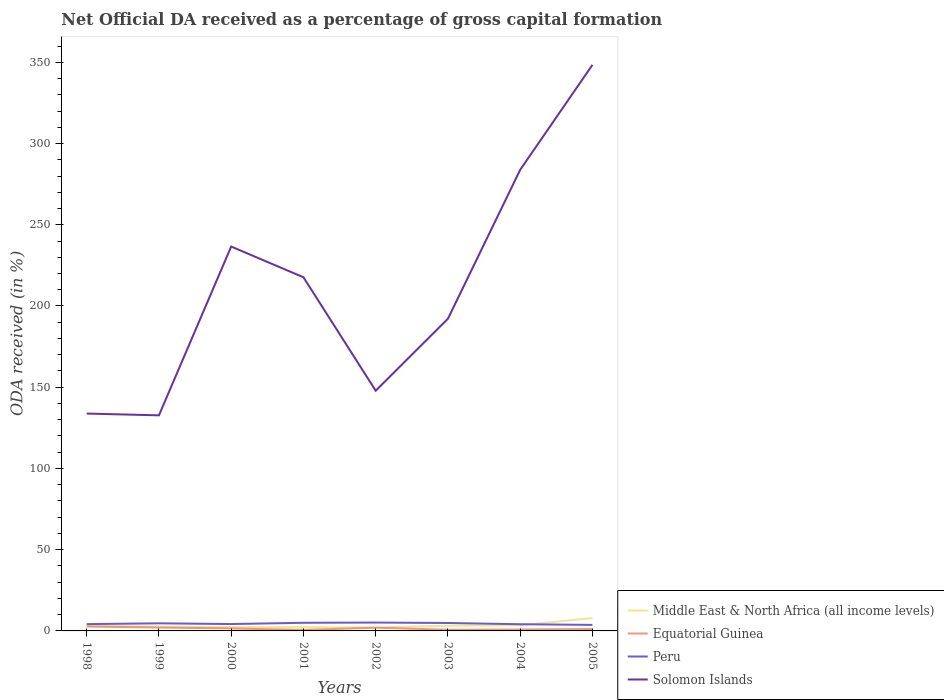How many different coloured lines are there?
Give a very brief answer. 4. Is the number of lines equal to the number of legend labels?
Your answer should be compact. Yes. Across all years, what is the maximum net ODA received in Middle East & North Africa (all income levels)?
Provide a short and direct response. 2.15. In which year was the net ODA received in Solomon Islands maximum?
Give a very brief answer. 1999. What is the total net ODA received in Solomon Islands in the graph?
Your answer should be very brief. -59.48. What is the difference between the highest and the second highest net ODA received in Equatorial Guinea?
Your response must be concise. 2.1. Is the net ODA received in Middle East & North Africa (all income levels) strictly greater than the net ODA received in Solomon Islands over the years?
Your answer should be compact. Yes. How many lines are there?
Your response must be concise. 4. What is the difference between two consecutive major ticks on the Y-axis?
Your answer should be very brief. 50. Are the values on the major ticks of Y-axis written in scientific E-notation?
Your answer should be compact. No. Does the graph contain grids?
Your answer should be compact. No. How are the legend labels stacked?
Provide a short and direct response. Vertical. What is the title of the graph?
Provide a short and direct response. Net Official DA received as a percentage of gross capital formation. What is the label or title of the Y-axis?
Give a very brief answer. ODA received (in %). What is the ODA received (in %) in Middle East & North Africa (all income levels) in 1998?
Your answer should be very brief. 3.15. What is the ODA received (in %) of Equatorial Guinea in 1998?
Offer a very short reply. 2.72. What is the ODA received (in %) in Peru in 1998?
Keep it short and to the point. 4.19. What is the ODA received (in %) in Solomon Islands in 1998?
Provide a short and direct response. 133.79. What is the ODA received (in %) in Middle East & North Africa (all income levels) in 1999?
Give a very brief answer. 2.72. What is the ODA received (in %) in Equatorial Guinea in 1999?
Your response must be concise. 2.1. What is the ODA received (in %) in Peru in 1999?
Provide a short and direct response. 4.68. What is the ODA received (in %) in Solomon Islands in 1999?
Give a very brief answer. 132.69. What is the ODA received (in %) of Middle East & North Africa (all income levels) in 2000?
Make the answer very short. 2.32. What is the ODA received (in %) of Equatorial Guinea in 2000?
Your response must be concise. 1.55. What is the ODA received (in %) of Peru in 2000?
Offer a terse response. 4.23. What is the ODA received (in %) in Solomon Islands in 2000?
Make the answer very short. 236.59. What is the ODA received (in %) of Middle East & North Africa (all income levels) in 2001?
Your answer should be very brief. 2.3. What is the ODA received (in %) in Equatorial Guinea in 2001?
Offer a terse response. 0.61. What is the ODA received (in %) of Peru in 2001?
Give a very brief answer. 5.01. What is the ODA received (in %) in Solomon Islands in 2001?
Your response must be concise. 217.68. What is the ODA received (in %) of Middle East & North Africa (all income levels) in 2002?
Offer a very short reply. 2.15. What is the ODA received (in %) of Equatorial Guinea in 2002?
Make the answer very short. 2. What is the ODA received (in %) of Peru in 2002?
Ensure brevity in your answer.  5.14. What is the ODA received (in %) of Solomon Islands in 2002?
Offer a terse response. 147.85. What is the ODA received (in %) of Middle East & North Africa (all income levels) in 2003?
Offer a very short reply. 3.2. What is the ODA received (in %) in Equatorial Guinea in 2003?
Your response must be concise. 0.72. What is the ODA received (in %) in Peru in 2003?
Your answer should be compact. 4.88. What is the ODA received (in %) in Solomon Islands in 2003?
Your answer should be very brief. 192.17. What is the ODA received (in %) in Middle East & North Africa (all income levels) in 2004?
Your response must be concise. 3.5. What is the ODA received (in %) of Equatorial Guinea in 2004?
Give a very brief answer. 0.86. What is the ODA received (in %) of Peru in 2004?
Your answer should be compact. 4.12. What is the ODA received (in %) in Solomon Islands in 2004?
Offer a very short reply. 283.85. What is the ODA received (in %) of Middle East & North Africa (all income levels) in 2005?
Offer a terse response. 7.89. What is the ODA received (in %) in Equatorial Guinea in 2005?
Provide a succinct answer. 1.18. What is the ODA received (in %) of Peru in 2005?
Provide a succinct answer. 3.71. What is the ODA received (in %) in Solomon Islands in 2005?
Your response must be concise. 348.44. Across all years, what is the maximum ODA received (in %) in Middle East & North Africa (all income levels)?
Make the answer very short. 7.89. Across all years, what is the maximum ODA received (in %) in Equatorial Guinea?
Give a very brief answer. 2.72. Across all years, what is the maximum ODA received (in %) of Peru?
Keep it short and to the point. 5.14. Across all years, what is the maximum ODA received (in %) of Solomon Islands?
Give a very brief answer. 348.44. Across all years, what is the minimum ODA received (in %) of Middle East & North Africa (all income levels)?
Ensure brevity in your answer.  2.15. Across all years, what is the minimum ODA received (in %) of Equatorial Guinea?
Your answer should be very brief. 0.61. Across all years, what is the minimum ODA received (in %) in Peru?
Give a very brief answer. 3.71. Across all years, what is the minimum ODA received (in %) in Solomon Islands?
Offer a terse response. 132.69. What is the total ODA received (in %) in Middle East & North Africa (all income levels) in the graph?
Keep it short and to the point. 27.24. What is the total ODA received (in %) of Equatorial Guinea in the graph?
Give a very brief answer. 11.74. What is the total ODA received (in %) of Peru in the graph?
Offer a very short reply. 35.96. What is the total ODA received (in %) in Solomon Islands in the graph?
Your response must be concise. 1693.06. What is the difference between the ODA received (in %) of Middle East & North Africa (all income levels) in 1998 and that in 1999?
Your response must be concise. 0.42. What is the difference between the ODA received (in %) in Equatorial Guinea in 1998 and that in 1999?
Offer a very short reply. 0.62. What is the difference between the ODA received (in %) in Peru in 1998 and that in 1999?
Make the answer very short. -0.49. What is the difference between the ODA received (in %) of Solomon Islands in 1998 and that in 1999?
Your response must be concise. 1.1. What is the difference between the ODA received (in %) of Middle East & North Africa (all income levels) in 1998 and that in 2000?
Provide a succinct answer. 0.82. What is the difference between the ODA received (in %) of Equatorial Guinea in 1998 and that in 2000?
Provide a short and direct response. 1.17. What is the difference between the ODA received (in %) in Peru in 1998 and that in 2000?
Offer a very short reply. -0.04. What is the difference between the ODA received (in %) of Solomon Islands in 1998 and that in 2000?
Your response must be concise. -102.81. What is the difference between the ODA received (in %) in Middle East & North Africa (all income levels) in 1998 and that in 2001?
Ensure brevity in your answer.  0.84. What is the difference between the ODA received (in %) of Equatorial Guinea in 1998 and that in 2001?
Your answer should be compact. 2.1. What is the difference between the ODA received (in %) of Peru in 1998 and that in 2001?
Offer a very short reply. -0.82. What is the difference between the ODA received (in %) in Solomon Islands in 1998 and that in 2001?
Offer a terse response. -83.89. What is the difference between the ODA received (in %) of Middle East & North Africa (all income levels) in 1998 and that in 2002?
Your answer should be compact. 1. What is the difference between the ODA received (in %) in Equatorial Guinea in 1998 and that in 2002?
Provide a succinct answer. 0.71. What is the difference between the ODA received (in %) in Peru in 1998 and that in 2002?
Offer a very short reply. -0.95. What is the difference between the ODA received (in %) in Solomon Islands in 1998 and that in 2002?
Offer a terse response. -14.06. What is the difference between the ODA received (in %) of Middle East & North Africa (all income levels) in 1998 and that in 2003?
Your answer should be very brief. -0.05. What is the difference between the ODA received (in %) in Equatorial Guinea in 1998 and that in 2003?
Your response must be concise. 1.99. What is the difference between the ODA received (in %) in Peru in 1998 and that in 2003?
Provide a short and direct response. -0.69. What is the difference between the ODA received (in %) of Solomon Islands in 1998 and that in 2003?
Provide a short and direct response. -58.38. What is the difference between the ODA received (in %) of Middle East & North Africa (all income levels) in 1998 and that in 2004?
Ensure brevity in your answer.  -0.36. What is the difference between the ODA received (in %) of Equatorial Guinea in 1998 and that in 2004?
Your answer should be compact. 1.86. What is the difference between the ODA received (in %) in Peru in 1998 and that in 2004?
Make the answer very short. 0.07. What is the difference between the ODA received (in %) in Solomon Islands in 1998 and that in 2004?
Offer a very short reply. -150.07. What is the difference between the ODA received (in %) in Middle East & North Africa (all income levels) in 1998 and that in 2005?
Your response must be concise. -4.75. What is the difference between the ODA received (in %) of Equatorial Guinea in 1998 and that in 2005?
Give a very brief answer. 1.54. What is the difference between the ODA received (in %) in Peru in 1998 and that in 2005?
Give a very brief answer. 0.48. What is the difference between the ODA received (in %) of Solomon Islands in 1998 and that in 2005?
Provide a short and direct response. -214.65. What is the difference between the ODA received (in %) in Middle East & North Africa (all income levels) in 1999 and that in 2000?
Your answer should be compact. 0.4. What is the difference between the ODA received (in %) in Equatorial Guinea in 1999 and that in 2000?
Your answer should be compact. 0.55. What is the difference between the ODA received (in %) in Peru in 1999 and that in 2000?
Make the answer very short. 0.45. What is the difference between the ODA received (in %) in Solomon Islands in 1999 and that in 2000?
Keep it short and to the point. -103.91. What is the difference between the ODA received (in %) in Middle East & North Africa (all income levels) in 1999 and that in 2001?
Your response must be concise. 0.42. What is the difference between the ODA received (in %) of Equatorial Guinea in 1999 and that in 2001?
Your answer should be very brief. 1.49. What is the difference between the ODA received (in %) of Peru in 1999 and that in 2001?
Offer a terse response. -0.33. What is the difference between the ODA received (in %) of Solomon Islands in 1999 and that in 2001?
Offer a terse response. -84.99. What is the difference between the ODA received (in %) in Middle East & North Africa (all income levels) in 1999 and that in 2002?
Give a very brief answer. 0.57. What is the difference between the ODA received (in %) of Equatorial Guinea in 1999 and that in 2002?
Your answer should be compact. 0.1. What is the difference between the ODA received (in %) of Peru in 1999 and that in 2002?
Make the answer very short. -0.46. What is the difference between the ODA received (in %) in Solomon Islands in 1999 and that in 2002?
Keep it short and to the point. -15.16. What is the difference between the ODA received (in %) in Middle East & North Africa (all income levels) in 1999 and that in 2003?
Give a very brief answer. -0.48. What is the difference between the ODA received (in %) in Equatorial Guinea in 1999 and that in 2003?
Your answer should be very brief. 1.37. What is the difference between the ODA received (in %) in Peru in 1999 and that in 2003?
Offer a terse response. -0.2. What is the difference between the ODA received (in %) in Solomon Islands in 1999 and that in 2003?
Ensure brevity in your answer.  -59.48. What is the difference between the ODA received (in %) in Middle East & North Africa (all income levels) in 1999 and that in 2004?
Give a very brief answer. -0.78. What is the difference between the ODA received (in %) of Equatorial Guinea in 1999 and that in 2004?
Provide a short and direct response. 1.24. What is the difference between the ODA received (in %) in Peru in 1999 and that in 2004?
Your answer should be compact. 0.56. What is the difference between the ODA received (in %) of Solomon Islands in 1999 and that in 2004?
Give a very brief answer. -151.17. What is the difference between the ODA received (in %) of Middle East & North Africa (all income levels) in 1999 and that in 2005?
Ensure brevity in your answer.  -5.17. What is the difference between the ODA received (in %) in Equatorial Guinea in 1999 and that in 2005?
Make the answer very short. 0.92. What is the difference between the ODA received (in %) of Peru in 1999 and that in 2005?
Your response must be concise. 0.97. What is the difference between the ODA received (in %) in Solomon Islands in 1999 and that in 2005?
Offer a terse response. -215.75. What is the difference between the ODA received (in %) in Middle East & North Africa (all income levels) in 2000 and that in 2001?
Keep it short and to the point. 0.02. What is the difference between the ODA received (in %) in Equatorial Guinea in 2000 and that in 2001?
Provide a succinct answer. 0.94. What is the difference between the ODA received (in %) of Peru in 2000 and that in 2001?
Your answer should be compact. -0.78. What is the difference between the ODA received (in %) in Solomon Islands in 2000 and that in 2001?
Your response must be concise. 18.92. What is the difference between the ODA received (in %) in Middle East & North Africa (all income levels) in 2000 and that in 2002?
Your response must be concise. 0.17. What is the difference between the ODA received (in %) in Equatorial Guinea in 2000 and that in 2002?
Make the answer very short. -0.45. What is the difference between the ODA received (in %) in Peru in 2000 and that in 2002?
Provide a short and direct response. -0.91. What is the difference between the ODA received (in %) of Solomon Islands in 2000 and that in 2002?
Ensure brevity in your answer.  88.74. What is the difference between the ODA received (in %) of Middle East & North Africa (all income levels) in 2000 and that in 2003?
Your response must be concise. -0.87. What is the difference between the ODA received (in %) of Equatorial Guinea in 2000 and that in 2003?
Provide a short and direct response. 0.83. What is the difference between the ODA received (in %) in Peru in 2000 and that in 2003?
Give a very brief answer. -0.65. What is the difference between the ODA received (in %) of Solomon Islands in 2000 and that in 2003?
Your answer should be very brief. 44.42. What is the difference between the ODA received (in %) in Middle East & North Africa (all income levels) in 2000 and that in 2004?
Give a very brief answer. -1.18. What is the difference between the ODA received (in %) in Equatorial Guinea in 2000 and that in 2004?
Your answer should be compact. 0.69. What is the difference between the ODA received (in %) of Peru in 2000 and that in 2004?
Your answer should be very brief. 0.11. What is the difference between the ODA received (in %) in Solomon Islands in 2000 and that in 2004?
Provide a succinct answer. -47.26. What is the difference between the ODA received (in %) in Middle East & North Africa (all income levels) in 2000 and that in 2005?
Make the answer very short. -5.57. What is the difference between the ODA received (in %) of Equatorial Guinea in 2000 and that in 2005?
Give a very brief answer. 0.38. What is the difference between the ODA received (in %) of Peru in 2000 and that in 2005?
Give a very brief answer. 0.53. What is the difference between the ODA received (in %) of Solomon Islands in 2000 and that in 2005?
Your answer should be very brief. -111.85. What is the difference between the ODA received (in %) in Middle East & North Africa (all income levels) in 2001 and that in 2002?
Offer a terse response. 0.15. What is the difference between the ODA received (in %) of Equatorial Guinea in 2001 and that in 2002?
Keep it short and to the point. -1.39. What is the difference between the ODA received (in %) of Peru in 2001 and that in 2002?
Your response must be concise. -0.13. What is the difference between the ODA received (in %) of Solomon Islands in 2001 and that in 2002?
Your response must be concise. 69.82. What is the difference between the ODA received (in %) in Middle East & North Africa (all income levels) in 2001 and that in 2003?
Your answer should be very brief. -0.89. What is the difference between the ODA received (in %) in Equatorial Guinea in 2001 and that in 2003?
Offer a very short reply. -0.11. What is the difference between the ODA received (in %) of Peru in 2001 and that in 2003?
Make the answer very short. 0.13. What is the difference between the ODA received (in %) in Solomon Islands in 2001 and that in 2003?
Give a very brief answer. 25.51. What is the difference between the ODA received (in %) of Middle East & North Africa (all income levels) in 2001 and that in 2004?
Your answer should be very brief. -1.2. What is the difference between the ODA received (in %) in Equatorial Guinea in 2001 and that in 2004?
Provide a short and direct response. -0.25. What is the difference between the ODA received (in %) in Peru in 2001 and that in 2004?
Keep it short and to the point. 0.89. What is the difference between the ODA received (in %) of Solomon Islands in 2001 and that in 2004?
Your response must be concise. -66.18. What is the difference between the ODA received (in %) of Middle East & North Africa (all income levels) in 2001 and that in 2005?
Provide a short and direct response. -5.59. What is the difference between the ODA received (in %) of Equatorial Guinea in 2001 and that in 2005?
Give a very brief answer. -0.56. What is the difference between the ODA received (in %) in Peru in 2001 and that in 2005?
Offer a terse response. 1.3. What is the difference between the ODA received (in %) in Solomon Islands in 2001 and that in 2005?
Provide a short and direct response. -130.76. What is the difference between the ODA received (in %) in Middle East & North Africa (all income levels) in 2002 and that in 2003?
Your answer should be very brief. -1.05. What is the difference between the ODA received (in %) of Equatorial Guinea in 2002 and that in 2003?
Provide a short and direct response. 1.28. What is the difference between the ODA received (in %) of Peru in 2002 and that in 2003?
Your response must be concise. 0.26. What is the difference between the ODA received (in %) of Solomon Islands in 2002 and that in 2003?
Offer a very short reply. -44.32. What is the difference between the ODA received (in %) of Middle East & North Africa (all income levels) in 2002 and that in 2004?
Give a very brief answer. -1.35. What is the difference between the ODA received (in %) of Equatorial Guinea in 2002 and that in 2004?
Give a very brief answer. 1.14. What is the difference between the ODA received (in %) of Peru in 2002 and that in 2004?
Make the answer very short. 1.02. What is the difference between the ODA received (in %) in Solomon Islands in 2002 and that in 2004?
Offer a terse response. -136. What is the difference between the ODA received (in %) in Middle East & North Africa (all income levels) in 2002 and that in 2005?
Offer a terse response. -5.74. What is the difference between the ODA received (in %) in Equatorial Guinea in 2002 and that in 2005?
Your response must be concise. 0.83. What is the difference between the ODA received (in %) of Peru in 2002 and that in 2005?
Provide a succinct answer. 1.44. What is the difference between the ODA received (in %) in Solomon Islands in 2002 and that in 2005?
Ensure brevity in your answer.  -200.59. What is the difference between the ODA received (in %) of Middle East & North Africa (all income levels) in 2003 and that in 2004?
Your response must be concise. -0.31. What is the difference between the ODA received (in %) of Equatorial Guinea in 2003 and that in 2004?
Provide a succinct answer. -0.13. What is the difference between the ODA received (in %) in Peru in 2003 and that in 2004?
Offer a terse response. 0.76. What is the difference between the ODA received (in %) in Solomon Islands in 2003 and that in 2004?
Provide a succinct answer. -91.68. What is the difference between the ODA received (in %) of Middle East & North Africa (all income levels) in 2003 and that in 2005?
Provide a succinct answer. -4.7. What is the difference between the ODA received (in %) of Equatorial Guinea in 2003 and that in 2005?
Offer a terse response. -0.45. What is the difference between the ODA received (in %) in Peru in 2003 and that in 2005?
Ensure brevity in your answer.  1.18. What is the difference between the ODA received (in %) of Solomon Islands in 2003 and that in 2005?
Provide a succinct answer. -156.27. What is the difference between the ODA received (in %) of Middle East & North Africa (all income levels) in 2004 and that in 2005?
Make the answer very short. -4.39. What is the difference between the ODA received (in %) in Equatorial Guinea in 2004 and that in 2005?
Keep it short and to the point. -0.32. What is the difference between the ODA received (in %) of Peru in 2004 and that in 2005?
Provide a succinct answer. 0.42. What is the difference between the ODA received (in %) of Solomon Islands in 2004 and that in 2005?
Offer a very short reply. -64.58. What is the difference between the ODA received (in %) in Middle East & North Africa (all income levels) in 1998 and the ODA received (in %) in Equatorial Guinea in 1999?
Your response must be concise. 1.05. What is the difference between the ODA received (in %) of Middle East & North Africa (all income levels) in 1998 and the ODA received (in %) of Peru in 1999?
Your response must be concise. -1.53. What is the difference between the ODA received (in %) in Middle East & North Africa (all income levels) in 1998 and the ODA received (in %) in Solomon Islands in 1999?
Offer a very short reply. -129.54. What is the difference between the ODA received (in %) of Equatorial Guinea in 1998 and the ODA received (in %) of Peru in 1999?
Ensure brevity in your answer.  -1.96. What is the difference between the ODA received (in %) of Equatorial Guinea in 1998 and the ODA received (in %) of Solomon Islands in 1999?
Provide a succinct answer. -129.97. What is the difference between the ODA received (in %) of Peru in 1998 and the ODA received (in %) of Solomon Islands in 1999?
Keep it short and to the point. -128.5. What is the difference between the ODA received (in %) in Middle East & North Africa (all income levels) in 1998 and the ODA received (in %) in Equatorial Guinea in 2000?
Your answer should be compact. 1.59. What is the difference between the ODA received (in %) in Middle East & North Africa (all income levels) in 1998 and the ODA received (in %) in Peru in 2000?
Give a very brief answer. -1.08. What is the difference between the ODA received (in %) of Middle East & North Africa (all income levels) in 1998 and the ODA received (in %) of Solomon Islands in 2000?
Offer a very short reply. -233.45. What is the difference between the ODA received (in %) of Equatorial Guinea in 1998 and the ODA received (in %) of Peru in 2000?
Give a very brief answer. -1.51. What is the difference between the ODA received (in %) in Equatorial Guinea in 1998 and the ODA received (in %) in Solomon Islands in 2000?
Provide a short and direct response. -233.88. What is the difference between the ODA received (in %) of Peru in 1998 and the ODA received (in %) of Solomon Islands in 2000?
Your answer should be very brief. -232.4. What is the difference between the ODA received (in %) in Middle East & North Africa (all income levels) in 1998 and the ODA received (in %) in Equatorial Guinea in 2001?
Provide a succinct answer. 2.53. What is the difference between the ODA received (in %) in Middle East & North Africa (all income levels) in 1998 and the ODA received (in %) in Peru in 2001?
Give a very brief answer. -1.86. What is the difference between the ODA received (in %) of Middle East & North Africa (all income levels) in 1998 and the ODA received (in %) of Solomon Islands in 2001?
Give a very brief answer. -214.53. What is the difference between the ODA received (in %) in Equatorial Guinea in 1998 and the ODA received (in %) in Peru in 2001?
Your answer should be compact. -2.29. What is the difference between the ODA received (in %) of Equatorial Guinea in 1998 and the ODA received (in %) of Solomon Islands in 2001?
Keep it short and to the point. -214.96. What is the difference between the ODA received (in %) of Peru in 1998 and the ODA received (in %) of Solomon Islands in 2001?
Ensure brevity in your answer.  -213.49. What is the difference between the ODA received (in %) in Middle East & North Africa (all income levels) in 1998 and the ODA received (in %) in Equatorial Guinea in 2002?
Offer a terse response. 1.14. What is the difference between the ODA received (in %) of Middle East & North Africa (all income levels) in 1998 and the ODA received (in %) of Peru in 2002?
Give a very brief answer. -2. What is the difference between the ODA received (in %) in Middle East & North Africa (all income levels) in 1998 and the ODA received (in %) in Solomon Islands in 2002?
Provide a succinct answer. -144.71. What is the difference between the ODA received (in %) in Equatorial Guinea in 1998 and the ODA received (in %) in Peru in 2002?
Provide a succinct answer. -2.43. What is the difference between the ODA received (in %) of Equatorial Guinea in 1998 and the ODA received (in %) of Solomon Islands in 2002?
Keep it short and to the point. -145.13. What is the difference between the ODA received (in %) of Peru in 1998 and the ODA received (in %) of Solomon Islands in 2002?
Provide a short and direct response. -143.66. What is the difference between the ODA received (in %) of Middle East & North Africa (all income levels) in 1998 and the ODA received (in %) of Equatorial Guinea in 2003?
Give a very brief answer. 2.42. What is the difference between the ODA received (in %) in Middle East & North Africa (all income levels) in 1998 and the ODA received (in %) in Peru in 2003?
Your response must be concise. -1.73. What is the difference between the ODA received (in %) in Middle East & North Africa (all income levels) in 1998 and the ODA received (in %) in Solomon Islands in 2003?
Your answer should be compact. -189.02. What is the difference between the ODA received (in %) of Equatorial Guinea in 1998 and the ODA received (in %) of Peru in 2003?
Give a very brief answer. -2.16. What is the difference between the ODA received (in %) in Equatorial Guinea in 1998 and the ODA received (in %) in Solomon Islands in 2003?
Give a very brief answer. -189.45. What is the difference between the ODA received (in %) in Peru in 1998 and the ODA received (in %) in Solomon Islands in 2003?
Make the answer very short. -187.98. What is the difference between the ODA received (in %) in Middle East & North Africa (all income levels) in 1998 and the ODA received (in %) in Equatorial Guinea in 2004?
Make the answer very short. 2.29. What is the difference between the ODA received (in %) in Middle East & North Africa (all income levels) in 1998 and the ODA received (in %) in Peru in 2004?
Offer a very short reply. -0.98. What is the difference between the ODA received (in %) in Middle East & North Africa (all income levels) in 1998 and the ODA received (in %) in Solomon Islands in 2004?
Ensure brevity in your answer.  -280.71. What is the difference between the ODA received (in %) in Equatorial Guinea in 1998 and the ODA received (in %) in Peru in 2004?
Make the answer very short. -1.41. What is the difference between the ODA received (in %) in Equatorial Guinea in 1998 and the ODA received (in %) in Solomon Islands in 2004?
Offer a very short reply. -281.14. What is the difference between the ODA received (in %) in Peru in 1998 and the ODA received (in %) in Solomon Islands in 2004?
Offer a very short reply. -279.66. What is the difference between the ODA received (in %) of Middle East & North Africa (all income levels) in 1998 and the ODA received (in %) of Equatorial Guinea in 2005?
Make the answer very short. 1.97. What is the difference between the ODA received (in %) in Middle East & North Africa (all income levels) in 1998 and the ODA received (in %) in Peru in 2005?
Keep it short and to the point. -0.56. What is the difference between the ODA received (in %) of Middle East & North Africa (all income levels) in 1998 and the ODA received (in %) of Solomon Islands in 2005?
Your answer should be very brief. -345.29. What is the difference between the ODA received (in %) in Equatorial Guinea in 1998 and the ODA received (in %) in Peru in 2005?
Offer a very short reply. -0.99. What is the difference between the ODA received (in %) in Equatorial Guinea in 1998 and the ODA received (in %) in Solomon Islands in 2005?
Offer a very short reply. -345.72. What is the difference between the ODA received (in %) in Peru in 1998 and the ODA received (in %) in Solomon Islands in 2005?
Provide a short and direct response. -344.25. What is the difference between the ODA received (in %) of Middle East & North Africa (all income levels) in 1999 and the ODA received (in %) of Equatorial Guinea in 2000?
Your answer should be compact. 1.17. What is the difference between the ODA received (in %) in Middle East & North Africa (all income levels) in 1999 and the ODA received (in %) in Peru in 2000?
Your answer should be compact. -1.51. What is the difference between the ODA received (in %) of Middle East & North Africa (all income levels) in 1999 and the ODA received (in %) of Solomon Islands in 2000?
Give a very brief answer. -233.87. What is the difference between the ODA received (in %) in Equatorial Guinea in 1999 and the ODA received (in %) in Peru in 2000?
Provide a succinct answer. -2.13. What is the difference between the ODA received (in %) in Equatorial Guinea in 1999 and the ODA received (in %) in Solomon Islands in 2000?
Keep it short and to the point. -234.49. What is the difference between the ODA received (in %) in Peru in 1999 and the ODA received (in %) in Solomon Islands in 2000?
Provide a short and direct response. -231.91. What is the difference between the ODA received (in %) in Middle East & North Africa (all income levels) in 1999 and the ODA received (in %) in Equatorial Guinea in 2001?
Your answer should be very brief. 2.11. What is the difference between the ODA received (in %) in Middle East & North Africa (all income levels) in 1999 and the ODA received (in %) in Peru in 2001?
Your answer should be compact. -2.29. What is the difference between the ODA received (in %) in Middle East & North Africa (all income levels) in 1999 and the ODA received (in %) in Solomon Islands in 2001?
Offer a terse response. -214.95. What is the difference between the ODA received (in %) of Equatorial Guinea in 1999 and the ODA received (in %) of Peru in 2001?
Your response must be concise. -2.91. What is the difference between the ODA received (in %) of Equatorial Guinea in 1999 and the ODA received (in %) of Solomon Islands in 2001?
Keep it short and to the point. -215.58. What is the difference between the ODA received (in %) of Peru in 1999 and the ODA received (in %) of Solomon Islands in 2001?
Ensure brevity in your answer.  -212.99. What is the difference between the ODA received (in %) of Middle East & North Africa (all income levels) in 1999 and the ODA received (in %) of Equatorial Guinea in 2002?
Provide a succinct answer. 0.72. What is the difference between the ODA received (in %) in Middle East & North Africa (all income levels) in 1999 and the ODA received (in %) in Peru in 2002?
Offer a terse response. -2.42. What is the difference between the ODA received (in %) in Middle East & North Africa (all income levels) in 1999 and the ODA received (in %) in Solomon Islands in 2002?
Give a very brief answer. -145.13. What is the difference between the ODA received (in %) of Equatorial Guinea in 1999 and the ODA received (in %) of Peru in 2002?
Offer a terse response. -3.04. What is the difference between the ODA received (in %) of Equatorial Guinea in 1999 and the ODA received (in %) of Solomon Islands in 2002?
Provide a short and direct response. -145.75. What is the difference between the ODA received (in %) of Peru in 1999 and the ODA received (in %) of Solomon Islands in 2002?
Ensure brevity in your answer.  -143.17. What is the difference between the ODA received (in %) of Middle East & North Africa (all income levels) in 1999 and the ODA received (in %) of Equatorial Guinea in 2003?
Make the answer very short. 2. What is the difference between the ODA received (in %) in Middle East & North Africa (all income levels) in 1999 and the ODA received (in %) in Peru in 2003?
Your answer should be very brief. -2.16. What is the difference between the ODA received (in %) in Middle East & North Africa (all income levels) in 1999 and the ODA received (in %) in Solomon Islands in 2003?
Your answer should be compact. -189.45. What is the difference between the ODA received (in %) of Equatorial Guinea in 1999 and the ODA received (in %) of Peru in 2003?
Your answer should be compact. -2.78. What is the difference between the ODA received (in %) of Equatorial Guinea in 1999 and the ODA received (in %) of Solomon Islands in 2003?
Offer a terse response. -190.07. What is the difference between the ODA received (in %) in Peru in 1999 and the ODA received (in %) in Solomon Islands in 2003?
Provide a short and direct response. -187.49. What is the difference between the ODA received (in %) in Middle East & North Africa (all income levels) in 1999 and the ODA received (in %) in Equatorial Guinea in 2004?
Make the answer very short. 1.86. What is the difference between the ODA received (in %) in Middle East & North Africa (all income levels) in 1999 and the ODA received (in %) in Peru in 2004?
Provide a short and direct response. -1.4. What is the difference between the ODA received (in %) of Middle East & North Africa (all income levels) in 1999 and the ODA received (in %) of Solomon Islands in 2004?
Your response must be concise. -281.13. What is the difference between the ODA received (in %) of Equatorial Guinea in 1999 and the ODA received (in %) of Peru in 2004?
Provide a short and direct response. -2.02. What is the difference between the ODA received (in %) of Equatorial Guinea in 1999 and the ODA received (in %) of Solomon Islands in 2004?
Provide a succinct answer. -281.75. What is the difference between the ODA received (in %) of Peru in 1999 and the ODA received (in %) of Solomon Islands in 2004?
Your answer should be very brief. -279.17. What is the difference between the ODA received (in %) in Middle East & North Africa (all income levels) in 1999 and the ODA received (in %) in Equatorial Guinea in 2005?
Make the answer very short. 1.55. What is the difference between the ODA received (in %) in Middle East & North Africa (all income levels) in 1999 and the ODA received (in %) in Peru in 2005?
Give a very brief answer. -0.98. What is the difference between the ODA received (in %) of Middle East & North Africa (all income levels) in 1999 and the ODA received (in %) of Solomon Islands in 2005?
Your answer should be compact. -345.72. What is the difference between the ODA received (in %) in Equatorial Guinea in 1999 and the ODA received (in %) in Peru in 2005?
Ensure brevity in your answer.  -1.61. What is the difference between the ODA received (in %) of Equatorial Guinea in 1999 and the ODA received (in %) of Solomon Islands in 2005?
Your response must be concise. -346.34. What is the difference between the ODA received (in %) in Peru in 1999 and the ODA received (in %) in Solomon Islands in 2005?
Your answer should be very brief. -343.76. What is the difference between the ODA received (in %) of Middle East & North Africa (all income levels) in 2000 and the ODA received (in %) of Equatorial Guinea in 2001?
Your answer should be compact. 1.71. What is the difference between the ODA received (in %) of Middle East & North Africa (all income levels) in 2000 and the ODA received (in %) of Peru in 2001?
Give a very brief answer. -2.68. What is the difference between the ODA received (in %) of Middle East & North Africa (all income levels) in 2000 and the ODA received (in %) of Solomon Islands in 2001?
Make the answer very short. -215.35. What is the difference between the ODA received (in %) of Equatorial Guinea in 2000 and the ODA received (in %) of Peru in 2001?
Ensure brevity in your answer.  -3.46. What is the difference between the ODA received (in %) of Equatorial Guinea in 2000 and the ODA received (in %) of Solomon Islands in 2001?
Offer a terse response. -216.12. What is the difference between the ODA received (in %) of Peru in 2000 and the ODA received (in %) of Solomon Islands in 2001?
Provide a succinct answer. -213.44. What is the difference between the ODA received (in %) in Middle East & North Africa (all income levels) in 2000 and the ODA received (in %) in Equatorial Guinea in 2002?
Make the answer very short. 0.32. What is the difference between the ODA received (in %) in Middle East & North Africa (all income levels) in 2000 and the ODA received (in %) in Peru in 2002?
Ensure brevity in your answer.  -2.82. What is the difference between the ODA received (in %) in Middle East & North Africa (all income levels) in 2000 and the ODA received (in %) in Solomon Islands in 2002?
Make the answer very short. -145.53. What is the difference between the ODA received (in %) in Equatorial Guinea in 2000 and the ODA received (in %) in Peru in 2002?
Provide a succinct answer. -3.59. What is the difference between the ODA received (in %) in Equatorial Guinea in 2000 and the ODA received (in %) in Solomon Islands in 2002?
Your answer should be very brief. -146.3. What is the difference between the ODA received (in %) in Peru in 2000 and the ODA received (in %) in Solomon Islands in 2002?
Offer a very short reply. -143.62. What is the difference between the ODA received (in %) of Middle East & North Africa (all income levels) in 2000 and the ODA received (in %) of Equatorial Guinea in 2003?
Keep it short and to the point. 1.6. What is the difference between the ODA received (in %) in Middle East & North Africa (all income levels) in 2000 and the ODA received (in %) in Peru in 2003?
Provide a succinct answer. -2.56. What is the difference between the ODA received (in %) of Middle East & North Africa (all income levels) in 2000 and the ODA received (in %) of Solomon Islands in 2003?
Your response must be concise. -189.85. What is the difference between the ODA received (in %) in Equatorial Guinea in 2000 and the ODA received (in %) in Peru in 2003?
Offer a very short reply. -3.33. What is the difference between the ODA received (in %) of Equatorial Guinea in 2000 and the ODA received (in %) of Solomon Islands in 2003?
Your answer should be compact. -190.62. What is the difference between the ODA received (in %) in Peru in 2000 and the ODA received (in %) in Solomon Islands in 2003?
Provide a succinct answer. -187.94. What is the difference between the ODA received (in %) of Middle East & North Africa (all income levels) in 2000 and the ODA received (in %) of Equatorial Guinea in 2004?
Your response must be concise. 1.47. What is the difference between the ODA received (in %) of Middle East & North Africa (all income levels) in 2000 and the ODA received (in %) of Peru in 2004?
Provide a succinct answer. -1.8. What is the difference between the ODA received (in %) in Middle East & North Africa (all income levels) in 2000 and the ODA received (in %) in Solomon Islands in 2004?
Ensure brevity in your answer.  -281.53. What is the difference between the ODA received (in %) of Equatorial Guinea in 2000 and the ODA received (in %) of Peru in 2004?
Your response must be concise. -2.57. What is the difference between the ODA received (in %) of Equatorial Guinea in 2000 and the ODA received (in %) of Solomon Islands in 2004?
Your answer should be very brief. -282.3. What is the difference between the ODA received (in %) of Peru in 2000 and the ODA received (in %) of Solomon Islands in 2004?
Ensure brevity in your answer.  -279.62. What is the difference between the ODA received (in %) in Middle East & North Africa (all income levels) in 2000 and the ODA received (in %) in Equatorial Guinea in 2005?
Give a very brief answer. 1.15. What is the difference between the ODA received (in %) of Middle East & North Africa (all income levels) in 2000 and the ODA received (in %) of Peru in 2005?
Provide a short and direct response. -1.38. What is the difference between the ODA received (in %) of Middle East & North Africa (all income levels) in 2000 and the ODA received (in %) of Solomon Islands in 2005?
Give a very brief answer. -346.11. What is the difference between the ODA received (in %) of Equatorial Guinea in 2000 and the ODA received (in %) of Peru in 2005?
Provide a short and direct response. -2.15. What is the difference between the ODA received (in %) in Equatorial Guinea in 2000 and the ODA received (in %) in Solomon Islands in 2005?
Keep it short and to the point. -346.89. What is the difference between the ODA received (in %) in Peru in 2000 and the ODA received (in %) in Solomon Islands in 2005?
Your answer should be very brief. -344.21. What is the difference between the ODA received (in %) in Middle East & North Africa (all income levels) in 2001 and the ODA received (in %) in Equatorial Guinea in 2002?
Give a very brief answer. 0.3. What is the difference between the ODA received (in %) in Middle East & North Africa (all income levels) in 2001 and the ODA received (in %) in Peru in 2002?
Ensure brevity in your answer.  -2.84. What is the difference between the ODA received (in %) in Middle East & North Africa (all income levels) in 2001 and the ODA received (in %) in Solomon Islands in 2002?
Your answer should be compact. -145.55. What is the difference between the ODA received (in %) in Equatorial Guinea in 2001 and the ODA received (in %) in Peru in 2002?
Offer a very short reply. -4.53. What is the difference between the ODA received (in %) in Equatorial Guinea in 2001 and the ODA received (in %) in Solomon Islands in 2002?
Offer a very short reply. -147.24. What is the difference between the ODA received (in %) in Peru in 2001 and the ODA received (in %) in Solomon Islands in 2002?
Offer a very short reply. -142.84. What is the difference between the ODA received (in %) of Middle East & North Africa (all income levels) in 2001 and the ODA received (in %) of Equatorial Guinea in 2003?
Your response must be concise. 1.58. What is the difference between the ODA received (in %) of Middle East & North Africa (all income levels) in 2001 and the ODA received (in %) of Peru in 2003?
Offer a very short reply. -2.58. What is the difference between the ODA received (in %) in Middle East & North Africa (all income levels) in 2001 and the ODA received (in %) in Solomon Islands in 2003?
Provide a succinct answer. -189.87. What is the difference between the ODA received (in %) of Equatorial Guinea in 2001 and the ODA received (in %) of Peru in 2003?
Offer a very short reply. -4.27. What is the difference between the ODA received (in %) of Equatorial Guinea in 2001 and the ODA received (in %) of Solomon Islands in 2003?
Keep it short and to the point. -191.56. What is the difference between the ODA received (in %) of Peru in 2001 and the ODA received (in %) of Solomon Islands in 2003?
Make the answer very short. -187.16. What is the difference between the ODA received (in %) in Middle East & North Africa (all income levels) in 2001 and the ODA received (in %) in Equatorial Guinea in 2004?
Provide a succinct answer. 1.45. What is the difference between the ODA received (in %) of Middle East & North Africa (all income levels) in 2001 and the ODA received (in %) of Peru in 2004?
Your answer should be compact. -1.82. What is the difference between the ODA received (in %) in Middle East & North Africa (all income levels) in 2001 and the ODA received (in %) in Solomon Islands in 2004?
Your answer should be very brief. -281.55. What is the difference between the ODA received (in %) in Equatorial Guinea in 2001 and the ODA received (in %) in Peru in 2004?
Provide a short and direct response. -3.51. What is the difference between the ODA received (in %) of Equatorial Guinea in 2001 and the ODA received (in %) of Solomon Islands in 2004?
Provide a short and direct response. -283.24. What is the difference between the ODA received (in %) in Peru in 2001 and the ODA received (in %) in Solomon Islands in 2004?
Give a very brief answer. -278.84. What is the difference between the ODA received (in %) of Middle East & North Africa (all income levels) in 2001 and the ODA received (in %) of Equatorial Guinea in 2005?
Keep it short and to the point. 1.13. What is the difference between the ODA received (in %) of Middle East & North Africa (all income levels) in 2001 and the ODA received (in %) of Peru in 2005?
Keep it short and to the point. -1.4. What is the difference between the ODA received (in %) in Middle East & North Africa (all income levels) in 2001 and the ODA received (in %) in Solomon Islands in 2005?
Provide a succinct answer. -346.13. What is the difference between the ODA received (in %) in Equatorial Guinea in 2001 and the ODA received (in %) in Peru in 2005?
Ensure brevity in your answer.  -3.09. What is the difference between the ODA received (in %) in Equatorial Guinea in 2001 and the ODA received (in %) in Solomon Islands in 2005?
Give a very brief answer. -347.83. What is the difference between the ODA received (in %) of Peru in 2001 and the ODA received (in %) of Solomon Islands in 2005?
Your answer should be very brief. -343.43. What is the difference between the ODA received (in %) in Middle East & North Africa (all income levels) in 2002 and the ODA received (in %) in Equatorial Guinea in 2003?
Offer a terse response. 1.43. What is the difference between the ODA received (in %) in Middle East & North Africa (all income levels) in 2002 and the ODA received (in %) in Peru in 2003?
Your answer should be very brief. -2.73. What is the difference between the ODA received (in %) in Middle East & North Africa (all income levels) in 2002 and the ODA received (in %) in Solomon Islands in 2003?
Make the answer very short. -190.02. What is the difference between the ODA received (in %) in Equatorial Guinea in 2002 and the ODA received (in %) in Peru in 2003?
Make the answer very short. -2.88. What is the difference between the ODA received (in %) in Equatorial Guinea in 2002 and the ODA received (in %) in Solomon Islands in 2003?
Your answer should be very brief. -190.17. What is the difference between the ODA received (in %) in Peru in 2002 and the ODA received (in %) in Solomon Islands in 2003?
Ensure brevity in your answer.  -187.03. What is the difference between the ODA received (in %) in Middle East & North Africa (all income levels) in 2002 and the ODA received (in %) in Equatorial Guinea in 2004?
Provide a short and direct response. 1.29. What is the difference between the ODA received (in %) of Middle East & North Africa (all income levels) in 2002 and the ODA received (in %) of Peru in 2004?
Your answer should be compact. -1.97. What is the difference between the ODA received (in %) in Middle East & North Africa (all income levels) in 2002 and the ODA received (in %) in Solomon Islands in 2004?
Your answer should be very brief. -281.7. What is the difference between the ODA received (in %) of Equatorial Guinea in 2002 and the ODA received (in %) of Peru in 2004?
Provide a short and direct response. -2.12. What is the difference between the ODA received (in %) in Equatorial Guinea in 2002 and the ODA received (in %) in Solomon Islands in 2004?
Your answer should be compact. -281.85. What is the difference between the ODA received (in %) in Peru in 2002 and the ODA received (in %) in Solomon Islands in 2004?
Ensure brevity in your answer.  -278.71. What is the difference between the ODA received (in %) in Middle East & North Africa (all income levels) in 2002 and the ODA received (in %) in Equatorial Guinea in 2005?
Keep it short and to the point. 0.98. What is the difference between the ODA received (in %) in Middle East & North Africa (all income levels) in 2002 and the ODA received (in %) in Peru in 2005?
Provide a succinct answer. -1.55. What is the difference between the ODA received (in %) of Middle East & North Africa (all income levels) in 2002 and the ODA received (in %) of Solomon Islands in 2005?
Give a very brief answer. -346.29. What is the difference between the ODA received (in %) in Equatorial Guinea in 2002 and the ODA received (in %) in Peru in 2005?
Your answer should be compact. -1.7. What is the difference between the ODA received (in %) of Equatorial Guinea in 2002 and the ODA received (in %) of Solomon Islands in 2005?
Provide a short and direct response. -346.44. What is the difference between the ODA received (in %) of Peru in 2002 and the ODA received (in %) of Solomon Islands in 2005?
Your answer should be very brief. -343.29. What is the difference between the ODA received (in %) of Middle East & North Africa (all income levels) in 2003 and the ODA received (in %) of Equatorial Guinea in 2004?
Your answer should be compact. 2.34. What is the difference between the ODA received (in %) of Middle East & North Africa (all income levels) in 2003 and the ODA received (in %) of Peru in 2004?
Your answer should be very brief. -0.93. What is the difference between the ODA received (in %) of Middle East & North Africa (all income levels) in 2003 and the ODA received (in %) of Solomon Islands in 2004?
Your answer should be compact. -280.66. What is the difference between the ODA received (in %) of Equatorial Guinea in 2003 and the ODA received (in %) of Peru in 2004?
Your response must be concise. -3.4. What is the difference between the ODA received (in %) of Equatorial Guinea in 2003 and the ODA received (in %) of Solomon Islands in 2004?
Ensure brevity in your answer.  -283.13. What is the difference between the ODA received (in %) in Peru in 2003 and the ODA received (in %) in Solomon Islands in 2004?
Keep it short and to the point. -278.97. What is the difference between the ODA received (in %) of Middle East & North Africa (all income levels) in 2003 and the ODA received (in %) of Equatorial Guinea in 2005?
Make the answer very short. 2.02. What is the difference between the ODA received (in %) in Middle East & North Africa (all income levels) in 2003 and the ODA received (in %) in Peru in 2005?
Ensure brevity in your answer.  -0.51. What is the difference between the ODA received (in %) of Middle East & North Africa (all income levels) in 2003 and the ODA received (in %) of Solomon Islands in 2005?
Provide a succinct answer. -345.24. What is the difference between the ODA received (in %) of Equatorial Guinea in 2003 and the ODA received (in %) of Peru in 2005?
Make the answer very short. -2.98. What is the difference between the ODA received (in %) of Equatorial Guinea in 2003 and the ODA received (in %) of Solomon Islands in 2005?
Ensure brevity in your answer.  -347.71. What is the difference between the ODA received (in %) in Peru in 2003 and the ODA received (in %) in Solomon Islands in 2005?
Your answer should be very brief. -343.56. What is the difference between the ODA received (in %) in Middle East & North Africa (all income levels) in 2004 and the ODA received (in %) in Equatorial Guinea in 2005?
Offer a terse response. 2.33. What is the difference between the ODA received (in %) of Middle East & North Africa (all income levels) in 2004 and the ODA received (in %) of Peru in 2005?
Your answer should be compact. -0.2. What is the difference between the ODA received (in %) in Middle East & North Africa (all income levels) in 2004 and the ODA received (in %) in Solomon Islands in 2005?
Offer a terse response. -344.94. What is the difference between the ODA received (in %) in Equatorial Guinea in 2004 and the ODA received (in %) in Peru in 2005?
Your answer should be very brief. -2.85. What is the difference between the ODA received (in %) of Equatorial Guinea in 2004 and the ODA received (in %) of Solomon Islands in 2005?
Offer a very short reply. -347.58. What is the difference between the ODA received (in %) in Peru in 2004 and the ODA received (in %) in Solomon Islands in 2005?
Make the answer very short. -344.32. What is the average ODA received (in %) of Middle East & North Africa (all income levels) per year?
Your answer should be compact. 3.41. What is the average ODA received (in %) of Equatorial Guinea per year?
Your answer should be compact. 1.47. What is the average ODA received (in %) in Peru per year?
Your answer should be compact. 4.5. What is the average ODA received (in %) in Solomon Islands per year?
Offer a terse response. 211.63. In the year 1998, what is the difference between the ODA received (in %) of Middle East & North Africa (all income levels) and ODA received (in %) of Equatorial Guinea?
Your answer should be compact. 0.43. In the year 1998, what is the difference between the ODA received (in %) of Middle East & North Africa (all income levels) and ODA received (in %) of Peru?
Provide a succinct answer. -1.04. In the year 1998, what is the difference between the ODA received (in %) of Middle East & North Africa (all income levels) and ODA received (in %) of Solomon Islands?
Keep it short and to the point. -130.64. In the year 1998, what is the difference between the ODA received (in %) in Equatorial Guinea and ODA received (in %) in Peru?
Provide a short and direct response. -1.47. In the year 1998, what is the difference between the ODA received (in %) of Equatorial Guinea and ODA received (in %) of Solomon Islands?
Provide a short and direct response. -131.07. In the year 1998, what is the difference between the ODA received (in %) in Peru and ODA received (in %) in Solomon Islands?
Your answer should be very brief. -129.6. In the year 1999, what is the difference between the ODA received (in %) in Middle East & North Africa (all income levels) and ODA received (in %) in Equatorial Guinea?
Give a very brief answer. 0.62. In the year 1999, what is the difference between the ODA received (in %) in Middle East & North Africa (all income levels) and ODA received (in %) in Peru?
Provide a short and direct response. -1.96. In the year 1999, what is the difference between the ODA received (in %) of Middle East & North Africa (all income levels) and ODA received (in %) of Solomon Islands?
Your answer should be very brief. -129.97. In the year 1999, what is the difference between the ODA received (in %) of Equatorial Guinea and ODA received (in %) of Peru?
Ensure brevity in your answer.  -2.58. In the year 1999, what is the difference between the ODA received (in %) of Equatorial Guinea and ODA received (in %) of Solomon Islands?
Provide a short and direct response. -130.59. In the year 1999, what is the difference between the ODA received (in %) of Peru and ODA received (in %) of Solomon Islands?
Your answer should be compact. -128.01. In the year 2000, what is the difference between the ODA received (in %) in Middle East & North Africa (all income levels) and ODA received (in %) in Equatorial Guinea?
Offer a terse response. 0.77. In the year 2000, what is the difference between the ODA received (in %) in Middle East & North Africa (all income levels) and ODA received (in %) in Peru?
Your answer should be very brief. -1.91. In the year 2000, what is the difference between the ODA received (in %) of Middle East & North Africa (all income levels) and ODA received (in %) of Solomon Islands?
Provide a short and direct response. -234.27. In the year 2000, what is the difference between the ODA received (in %) in Equatorial Guinea and ODA received (in %) in Peru?
Offer a terse response. -2.68. In the year 2000, what is the difference between the ODA received (in %) of Equatorial Guinea and ODA received (in %) of Solomon Islands?
Your answer should be very brief. -235.04. In the year 2000, what is the difference between the ODA received (in %) in Peru and ODA received (in %) in Solomon Islands?
Offer a terse response. -232.36. In the year 2001, what is the difference between the ODA received (in %) in Middle East & North Africa (all income levels) and ODA received (in %) in Equatorial Guinea?
Offer a very short reply. 1.69. In the year 2001, what is the difference between the ODA received (in %) in Middle East & North Africa (all income levels) and ODA received (in %) in Peru?
Give a very brief answer. -2.7. In the year 2001, what is the difference between the ODA received (in %) of Middle East & North Africa (all income levels) and ODA received (in %) of Solomon Islands?
Offer a very short reply. -215.37. In the year 2001, what is the difference between the ODA received (in %) of Equatorial Guinea and ODA received (in %) of Peru?
Make the answer very short. -4.4. In the year 2001, what is the difference between the ODA received (in %) of Equatorial Guinea and ODA received (in %) of Solomon Islands?
Your response must be concise. -217.06. In the year 2001, what is the difference between the ODA received (in %) of Peru and ODA received (in %) of Solomon Islands?
Provide a succinct answer. -212.67. In the year 2002, what is the difference between the ODA received (in %) of Middle East & North Africa (all income levels) and ODA received (in %) of Equatorial Guinea?
Your answer should be very brief. 0.15. In the year 2002, what is the difference between the ODA received (in %) of Middle East & North Africa (all income levels) and ODA received (in %) of Peru?
Give a very brief answer. -2.99. In the year 2002, what is the difference between the ODA received (in %) of Middle East & North Africa (all income levels) and ODA received (in %) of Solomon Islands?
Provide a short and direct response. -145.7. In the year 2002, what is the difference between the ODA received (in %) of Equatorial Guinea and ODA received (in %) of Peru?
Your response must be concise. -3.14. In the year 2002, what is the difference between the ODA received (in %) in Equatorial Guinea and ODA received (in %) in Solomon Islands?
Provide a succinct answer. -145.85. In the year 2002, what is the difference between the ODA received (in %) of Peru and ODA received (in %) of Solomon Islands?
Offer a very short reply. -142.71. In the year 2003, what is the difference between the ODA received (in %) of Middle East & North Africa (all income levels) and ODA received (in %) of Equatorial Guinea?
Make the answer very short. 2.47. In the year 2003, what is the difference between the ODA received (in %) in Middle East & North Africa (all income levels) and ODA received (in %) in Peru?
Give a very brief answer. -1.68. In the year 2003, what is the difference between the ODA received (in %) in Middle East & North Africa (all income levels) and ODA received (in %) in Solomon Islands?
Provide a succinct answer. -188.97. In the year 2003, what is the difference between the ODA received (in %) in Equatorial Guinea and ODA received (in %) in Peru?
Keep it short and to the point. -4.16. In the year 2003, what is the difference between the ODA received (in %) in Equatorial Guinea and ODA received (in %) in Solomon Islands?
Offer a very short reply. -191.45. In the year 2003, what is the difference between the ODA received (in %) in Peru and ODA received (in %) in Solomon Islands?
Make the answer very short. -187.29. In the year 2004, what is the difference between the ODA received (in %) in Middle East & North Africa (all income levels) and ODA received (in %) in Equatorial Guinea?
Provide a short and direct response. 2.65. In the year 2004, what is the difference between the ODA received (in %) in Middle East & North Africa (all income levels) and ODA received (in %) in Peru?
Provide a short and direct response. -0.62. In the year 2004, what is the difference between the ODA received (in %) in Middle East & North Africa (all income levels) and ODA received (in %) in Solomon Islands?
Your response must be concise. -280.35. In the year 2004, what is the difference between the ODA received (in %) in Equatorial Guinea and ODA received (in %) in Peru?
Your response must be concise. -3.26. In the year 2004, what is the difference between the ODA received (in %) of Equatorial Guinea and ODA received (in %) of Solomon Islands?
Offer a terse response. -283. In the year 2004, what is the difference between the ODA received (in %) in Peru and ODA received (in %) in Solomon Islands?
Offer a very short reply. -279.73. In the year 2005, what is the difference between the ODA received (in %) of Middle East & North Africa (all income levels) and ODA received (in %) of Equatorial Guinea?
Keep it short and to the point. 6.72. In the year 2005, what is the difference between the ODA received (in %) of Middle East & North Africa (all income levels) and ODA received (in %) of Peru?
Your answer should be very brief. 4.19. In the year 2005, what is the difference between the ODA received (in %) of Middle East & North Africa (all income levels) and ODA received (in %) of Solomon Islands?
Your answer should be compact. -340.55. In the year 2005, what is the difference between the ODA received (in %) in Equatorial Guinea and ODA received (in %) in Peru?
Offer a terse response. -2.53. In the year 2005, what is the difference between the ODA received (in %) in Equatorial Guinea and ODA received (in %) in Solomon Islands?
Offer a very short reply. -347.26. In the year 2005, what is the difference between the ODA received (in %) in Peru and ODA received (in %) in Solomon Islands?
Your response must be concise. -344.73. What is the ratio of the ODA received (in %) in Middle East & North Africa (all income levels) in 1998 to that in 1999?
Give a very brief answer. 1.16. What is the ratio of the ODA received (in %) in Equatorial Guinea in 1998 to that in 1999?
Your answer should be very brief. 1.29. What is the ratio of the ODA received (in %) in Peru in 1998 to that in 1999?
Give a very brief answer. 0.9. What is the ratio of the ODA received (in %) in Solomon Islands in 1998 to that in 1999?
Your answer should be very brief. 1.01. What is the ratio of the ODA received (in %) of Middle East & North Africa (all income levels) in 1998 to that in 2000?
Make the answer very short. 1.35. What is the ratio of the ODA received (in %) in Equatorial Guinea in 1998 to that in 2000?
Give a very brief answer. 1.75. What is the ratio of the ODA received (in %) of Solomon Islands in 1998 to that in 2000?
Ensure brevity in your answer.  0.57. What is the ratio of the ODA received (in %) in Middle East & North Africa (all income levels) in 1998 to that in 2001?
Keep it short and to the point. 1.37. What is the ratio of the ODA received (in %) in Equatorial Guinea in 1998 to that in 2001?
Your response must be concise. 4.43. What is the ratio of the ODA received (in %) in Peru in 1998 to that in 2001?
Give a very brief answer. 0.84. What is the ratio of the ODA received (in %) of Solomon Islands in 1998 to that in 2001?
Give a very brief answer. 0.61. What is the ratio of the ODA received (in %) of Middle East & North Africa (all income levels) in 1998 to that in 2002?
Provide a succinct answer. 1.46. What is the ratio of the ODA received (in %) of Equatorial Guinea in 1998 to that in 2002?
Provide a succinct answer. 1.36. What is the ratio of the ODA received (in %) of Peru in 1998 to that in 2002?
Provide a succinct answer. 0.81. What is the ratio of the ODA received (in %) in Solomon Islands in 1998 to that in 2002?
Your response must be concise. 0.9. What is the ratio of the ODA received (in %) in Middle East & North Africa (all income levels) in 1998 to that in 2003?
Make the answer very short. 0.98. What is the ratio of the ODA received (in %) of Equatorial Guinea in 1998 to that in 2003?
Keep it short and to the point. 3.75. What is the ratio of the ODA received (in %) in Peru in 1998 to that in 2003?
Ensure brevity in your answer.  0.86. What is the ratio of the ODA received (in %) in Solomon Islands in 1998 to that in 2003?
Your answer should be very brief. 0.7. What is the ratio of the ODA received (in %) in Middle East & North Africa (all income levels) in 1998 to that in 2004?
Offer a terse response. 0.9. What is the ratio of the ODA received (in %) in Equatorial Guinea in 1998 to that in 2004?
Your answer should be compact. 3.17. What is the ratio of the ODA received (in %) in Peru in 1998 to that in 2004?
Your answer should be compact. 1.02. What is the ratio of the ODA received (in %) in Solomon Islands in 1998 to that in 2004?
Make the answer very short. 0.47. What is the ratio of the ODA received (in %) in Middle East & North Africa (all income levels) in 1998 to that in 2005?
Offer a terse response. 0.4. What is the ratio of the ODA received (in %) in Equatorial Guinea in 1998 to that in 2005?
Offer a terse response. 2.31. What is the ratio of the ODA received (in %) of Peru in 1998 to that in 2005?
Your response must be concise. 1.13. What is the ratio of the ODA received (in %) of Solomon Islands in 1998 to that in 2005?
Make the answer very short. 0.38. What is the ratio of the ODA received (in %) of Middle East & North Africa (all income levels) in 1999 to that in 2000?
Keep it short and to the point. 1.17. What is the ratio of the ODA received (in %) in Equatorial Guinea in 1999 to that in 2000?
Your response must be concise. 1.35. What is the ratio of the ODA received (in %) in Peru in 1999 to that in 2000?
Offer a very short reply. 1.11. What is the ratio of the ODA received (in %) of Solomon Islands in 1999 to that in 2000?
Keep it short and to the point. 0.56. What is the ratio of the ODA received (in %) of Middle East & North Africa (all income levels) in 1999 to that in 2001?
Your answer should be very brief. 1.18. What is the ratio of the ODA received (in %) in Equatorial Guinea in 1999 to that in 2001?
Offer a terse response. 3.43. What is the ratio of the ODA received (in %) in Peru in 1999 to that in 2001?
Your response must be concise. 0.93. What is the ratio of the ODA received (in %) in Solomon Islands in 1999 to that in 2001?
Your answer should be compact. 0.61. What is the ratio of the ODA received (in %) in Middle East & North Africa (all income levels) in 1999 to that in 2002?
Your answer should be very brief. 1.27. What is the ratio of the ODA received (in %) in Equatorial Guinea in 1999 to that in 2002?
Your response must be concise. 1.05. What is the ratio of the ODA received (in %) in Peru in 1999 to that in 2002?
Offer a terse response. 0.91. What is the ratio of the ODA received (in %) in Solomon Islands in 1999 to that in 2002?
Give a very brief answer. 0.9. What is the ratio of the ODA received (in %) in Middle East & North Africa (all income levels) in 1999 to that in 2003?
Make the answer very short. 0.85. What is the ratio of the ODA received (in %) of Equatorial Guinea in 1999 to that in 2003?
Ensure brevity in your answer.  2.9. What is the ratio of the ODA received (in %) in Peru in 1999 to that in 2003?
Your answer should be compact. 0.96. What is the ratio of the ODA received (in %) of Solomon Islands in 1999 to that in 2003?
Give a very brief answer. 0.69. What is the ratio of the ODA received (in %) in Middle East & North Africa (all income levels) in 1999 to that in 2004?
Your answer should be compact. 0.78. What is the ratio of the ODA received (in %) of Equatorial Guinea in 1999 to that in 2004?
Give a very brief answer. 2.45. What is the ratio of the ODA received (in %) of Peru in 1999 to that in 2004?
Provide a short and direct response. 1.14. What is the ratio of the ODA received (in %) in Solomon Islands in 1999 to that in 2004?
Give a very brief answer. 0.47. What is the ratio of the ODA received (in %) in Middle East & North Africa (all income levels) in 1999 to that in 2005?
Offer a very short reply. 0.34. What is the ratio of the ODA received (in %) of Equatorial Guinea in 1999 to that in 2005?
Give a very brief answer. 1.79. What is the ratio of the ODA received (in %) of Peru in 1999 to that in 2005?
Provide a succinct answer. 1.26. What is the ratio of the ODA received (in %) of Solomon Islands in 1999 to that in 2005?
Make the answer very short. 0.38. What is the ratio of the ODA received (in %) in Middle East & North Africa (all income levels) in 2000 to that in 2001?
Keep it short and to the point. 1.01. What is the ratio of the ODA received (in %) of Equatorial Guinea in 2000 to that in 2001?
Provide a succinct answer. 2.53. What is the ratio of the ODA received (in %) in Peru in 2000 to that in 2001?
Your answer should be very brief. 0.84. What is the ratio of the ODA received (in %) of Solomon Islands in 2000 to that in 2001?
Ensure brevity in your answer.  1.09. What is the ratio of the ODA received (in %) in Middle East & North Africa (all income levels) in 2000 to that in 2002?
Offer a terse response. 1.08. What is the ratio of the ODA received (in %) of Equatorial Guinea in 2000 to that in 2002?
Your response must be concise. 0.77. What is the ratio of the ODA received (in %) of Peru in 2000 to that in 2002?
Provide a succinct answer. 0.82. What is the ratio of the ODA received (in %) in Solomon Islands in 2000 to that in 2002?
Your answer should be compact. 1.6. What is the ratio of the ODA received (in %) of Middle East & North Africa (all income levels) in 2000 to that in 2003?
Give a very brief answer. 0.73. What is the ratio of the ODA received (in %) in Equatorial Guinea in 2000 to that in 2003?
Ensure brevity in your answer.  2.14. What is the ratio of the ODA received (in %) of Peru in 2000 to that in 2003?
Give a very brief answer. 0.87. What is the ratio of the ODA received (in %) of Solomon Islands in 2000 to that in 2003?
Give a very brief answer. 1.23. What is the ratio of the ODA received (in %) of Middle East & North Africa (all income levels) in 2000 to that in 2004?
Keep it short and to the point. 0.66. What is the ratio of the ODA received (in %) of Equatorial Guinea in 2000 to that in 2004?
Give a very brief answer. 1.81. What is the ratio of the ODA received (in %) in Peru in 2000 to that in 2004?
Make the answer very short. 1.03. What is the ratio of the ODA received (in %) in Solomon Islands in 2000 to that in 2004?
Your response must be concise. 0.83. What is the ratio of the ODA received (in %) in Middle East & North Africa (all income levels) in 2000 to that in 2005?
Provide a succinct answer. 0.29. What is the ratio of the ODA received (in %) in Equatorial Guinea in 2000 to that in 2005?
Your answer should be very brief. 1.32. What is the ratio of the ODA received (in %) of Peru in 2000 to that in 2005?
Provide a succinct answer. 1.14. What is the ratio of the ODA received (in %) of Solomon Islands in 2000 to that in 2005?
Give a very brief answer. 0.68. What is the ratio of the ODA received (in %) of Middle East & North Africa (all income levels) in 2001 to that in 2002?
Provide a short and direct response. 1.07. What is the ratio of the ODA received (in %) of Equatorial Guinea in 2001 to that in 2002?
Provide a succinct answer. 0.31. What is the ratio of the ODA received (in %) of Peru in 2001 to that in 2002?
Provide a succinct answer. 0.97. What is the ratio of the ODA received (in %) of Solomon Islands in 2001 to that in 2002?
Ensure brevity in your answer.  1.47. What is the ratio of the ODA received (in %) in Middle East & North Africa (all income levels) in 2001 to that in 2003?
Your response must be concise. 0.72. What is the ratio of the ODA received (in %) of Equatorial Guinea in 2001 to that in 2003?
Give a very brief answer. 0.85. What is the ratio of the ODA received (in %) of Peru in 2001 to that in 2003?
Make the answer very short. 1.03. What is the ratio of the ODA received (in %) in Solomon Islands in 2001 to that in 2003?
Give a very brief answer. 1.13. What is the ratio of the ODA received (in %) of Middle East & North Africa (all income levels) in 2001 to that in 2004?
Offer a very short reply. 0.66. What is the ratio of the ODA received (in %) in Equatorial Guinea in 2001 to that in 2004?
Give a very brief answer. 0.71. What is the ratio of the ODA received (in %) of Peru in 2001 to that in 2004?
Provide a succinct answer. 1.22. What is the ratio of the ODA received (in %) in Solomon Islands in 2001 to that in 2004?
Your response must be concise. 0.77. What is the ratio of the ODA received (in %) in Middle East & North Africa (all income levels) in 2001 to that in 2005?
Provide a succinct answer. 0.29. What is the ratio of the ODA received (in %) in Equatorial Guinea in 2001 to that in 2005?
Offer a terse response. 0.52. What is the ratio of the ODA received (in %) in Peru in 2001 to that in 2005?
Your answer should be very brief. 1.35. What is the ratio of the ODA received (in %) of Solomon Islands in 2001 to that in 2005?
Provide a succinct answer. 0.62. What is the ratio of the ODA received (in %) of Middle East & North Africa (all income levels) in 2002 to that in 2003?
Make the answer very short. 0.67. What is the ratio of the ODA received (in %) of Equatorial Guinea in 2002 to that in 2003?
Offer a very short reply. 2.76. What is the ratio of the ODA received (in %) of Peru in 2002 to that in 2003?
Your answer should be very brief. 1.05. What is the ratio of the ODA received (in %) of Solomon Islands in 2002 to that in 2003?
Provide a succinct answer. 0.77. What is the ratio of the ODA received (in %) in Middle East & North Africa (all income levels) in 2002 to that in 2004?
Your answer should be very brief. 0.61. What is the ratio of the ODA received (in %) in Equatorial Guinea in 2002 to that in 2004?
Your response must be concise. 2.33. What is the ratio of the ODA received (in %) in Peru in 2002 to that in 2004?
Your response must be concise. 1.25. What is the ratio of the ODA received (in %) in Solomon Islands in 2002 to that in 2004?
Your answer should be compact. 0.52. What is the ratio of the ODA received (in %) in Middle East & North Africa (all income levels) in 2002 to that in 2005?
Offer a terse response. 0.27. What is the ratio of the ODA received (in %) of Equatorial Guinea in 2002 to that in 2005?
Your answer should be compact. 1.7. What is the ratio of the ODA received (in %) of Peru in 2002 to that in 2005?
Give a very brief answer. 1.39. What is the ratio of the ODA received (in %) in Solomon Islands in 2002 to that in 2005?
Your response must be concise. 0.42. What is the ratio of the ODA received (in %) in Middle East & North Africa (all income levels) in 2003 to that in 2004?
Offer a terse response. 0.91. What is the ratio of the ODA received (in %) in Equatorial Guinea in 2003 to that in 2004?
Keep it short and to the point. 0.84. What is the ratio of the ODA received (in %) of Peru in 2003 to that in 2004?
Give a very brief answer. 1.18. What is the ratio of the ODA received (in %) in Solomon Islands in 2003 to that in 2004?
Keep it short and to the point. 0.68. What is the ratio of the ODA received (in %) of Middle East & North Africa (all income levels) in 2003 to that in 2005?
Provide a short and direct response. 0.41. What is the ratio of the ODA received (in %) in Equatorial Guinea in 2003 to that in 2005?
Your answer should be compact. 0.62. What is the ratio of the ODA received (in %) of Peru in 2003 to that in 2005?
Provide a short and direct response. 1.32. What is the ratio of the ODA received (in %) of Solomon Islands in 2003 to that in 2005?
Keep it short and to the point. 0.55. What is the ratio of the ODA received (in %) in Middle East & North Africa (all income levels) in 2004 to that in 2005?
Ensure brevity in your answer.  0.44. What is the ratio of the ODA received (in %) in Equatorial Guinea in 2004 to that in 2005?
Give a very brief answer. 0.73. What is the ratio of the ODA received (in %) of Peru in 2004 to that in 2005?
Give a very brief answer. 1.11. What is the ratio of the ODA received (in %) of Solomon Islands in 2004 to that in 2005?
Make the answer very short. 0.81. What is the difference between the highest and the second highest ODA received (in %) of Middle East & North Africa (all income levels)?
Provide a short and direct response. 4.39. What is the difference between the highest and the second highest ODA received (in %) of Equatorial Guinea?
Offer a very short reply. 0.62. What is the difference between the highest and the second highest ODA received (in %) of Peru?
Your answer should be compact. 0.13. What is the difference between the highest and the second highest ODA received (in %) in Solomon Islands?
Keep it short and to the point. 64.58. What is the difference between the highest and the lowest ODA received (in %) of Middle East & North Africa (all income levels)?
Your response must be concise. 5.74. What is the difference between the highest and the lowest ODA received (in %) of Equatorial Guinea?
Your answer should be very brief. 2.1. What is the difference between the highest and the lowest ODA received (in %) in Peru?
Ensure brevity in your answer.  1.44. What is the difference between the highest and the lowest ODA received (in %) in Solomon Islands?
Offer a terse response. 215.75. 